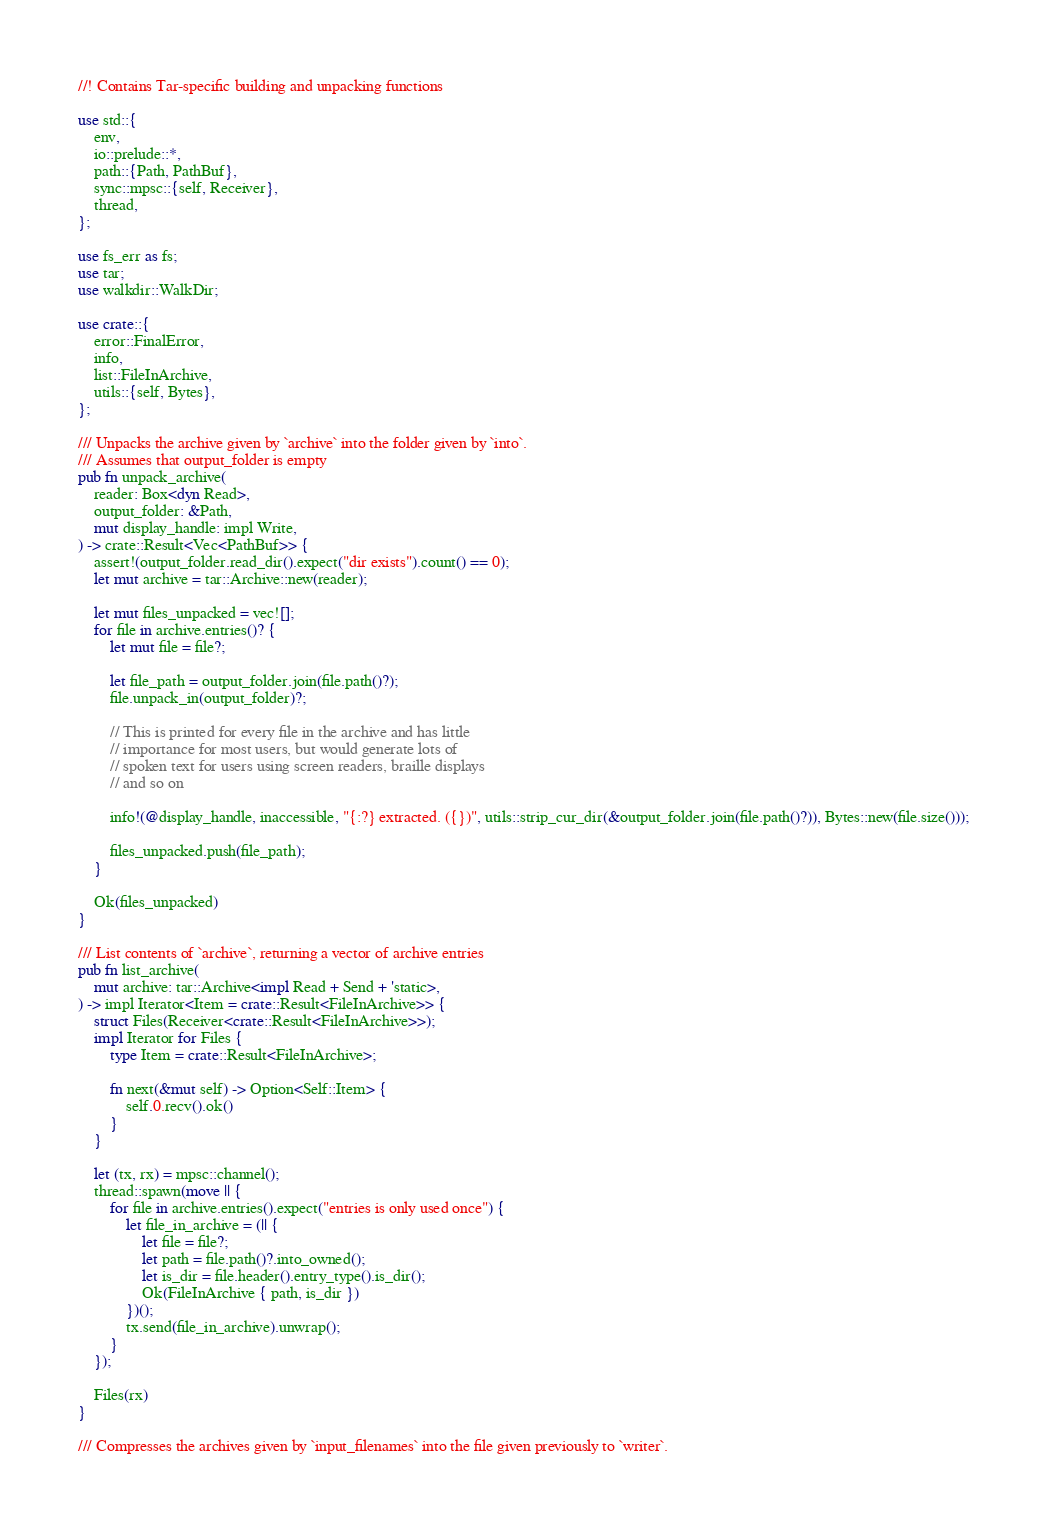<code> <loc_0><loc_0><loc_500><loc_500><_Rust_>//! Contains Tar-specific building and unpacking functions

use std::{
    env,
    io::prelude::*,
    path::{Path, PathBuf},
    sync::mpsc::{self, Receiver},
    thread,
};

use fs_err as fs;
use tar;
use walkdir::WalkDir;

use crate::{
    error::FinalError,
    info,
    list::FileInArchive,
    utils::{self, Bytes},
};

/// Unpacks the archive given by `archive` into the folder given by `into`.
/// Assumes that output_folder is empty
pub fn unpack_archive(
    reader: Box<dyn Read>,
    output_folder: &Path,
    mut display_handle: impl Write,
) -> crate::Result<Vec<PathBuf>> {
    assert!(output_folder.read_dir().expect("dir exists").count() == 0);
    let mut archive = tar::Archive::new(reader);

    let mut files_unpacked = vec![];
    for file in archive.entries()? {
        let mut file = file?;

        let file_path = output_folder.join(file.path()?);
        file.unpack_in(output_folder)?;

        // This is printed for every file in the archive and has little
        // importance for most users, but would generate lots of
        // spoken text for users using screen readers, braille displays
        // and so on

        info!(@display_handle, inaccessible, "{:?} extracted. ({})", utils::strip_cur_dir(&output_folder.join(file.path()?)), Bytes::new(file.size()));

        files_unpacked.push(file_path);
    }

    Ok(files_unpacked)
}

/// List contents of `archive`, returning a vector of archive entries
pub fn list_archive(
    mut archive: tar::Archive<impl Read + Send + 'static>,
) -> impl Iterator<Item = crate::Result<FileInArchive>> {
    struct Files(Receiver<crate::Result<FileInArchive>>);
    impl Iterator for Files {
        type Item = crate::Result<FileInArchive>;

        fn next(&mut self) -> Option<Self::Item> {
            self.0.recv().ok()
        }
    }

    let (tx, rx) = mpsc::channel();
    thread::spawn(move || {
        for file in archive.entries().expect("entries is only used once") {
            let file_in_archive = (|| {
                let file = file?;
                let path = file.path()?.into_owned();
                let is_dir = file.header().entry_type().is_dir();
                Ok(FileInArchive { path, is_dir })
            })();
            tx.send(file_in_archive).unwrap();
        }
    });

    Files(rx)
}

/// Compresses the archives given by `input_filenames` into the file given previously to `writer`.</code> 